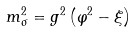Convert formula to latex. <formula><loc_0><loc_0><loc_500><loc_500>m _ { \sigma } ^ { 2 } = g ^ { 2 } \left ( \varphi ^ { 2 } - \xi \right )</formula> 